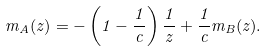Convert formula to latex. <formula><loc_0><loc_0><loc_500><loc_500>m _ { A } ( z ) = - \left ( 1 - \frac { 1 } { c } \right ) \frac { 1 } { z } + \frac { 1 } { c } m _ { B } ( z ) .</formula> 